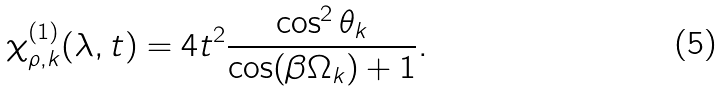Convert formula to latex. <formula><loc_0><loc_0><loc_500><loc_500>\chi _ { \rho , k } ^ { ( 1 ) } ( \lambda , t ) = 4 t ^ { 2 } \frac { \cos ^ { 2 } \theta _ { k } } { \cos ( \beta \Omega _ { k } ) + 1 } .</formula> 